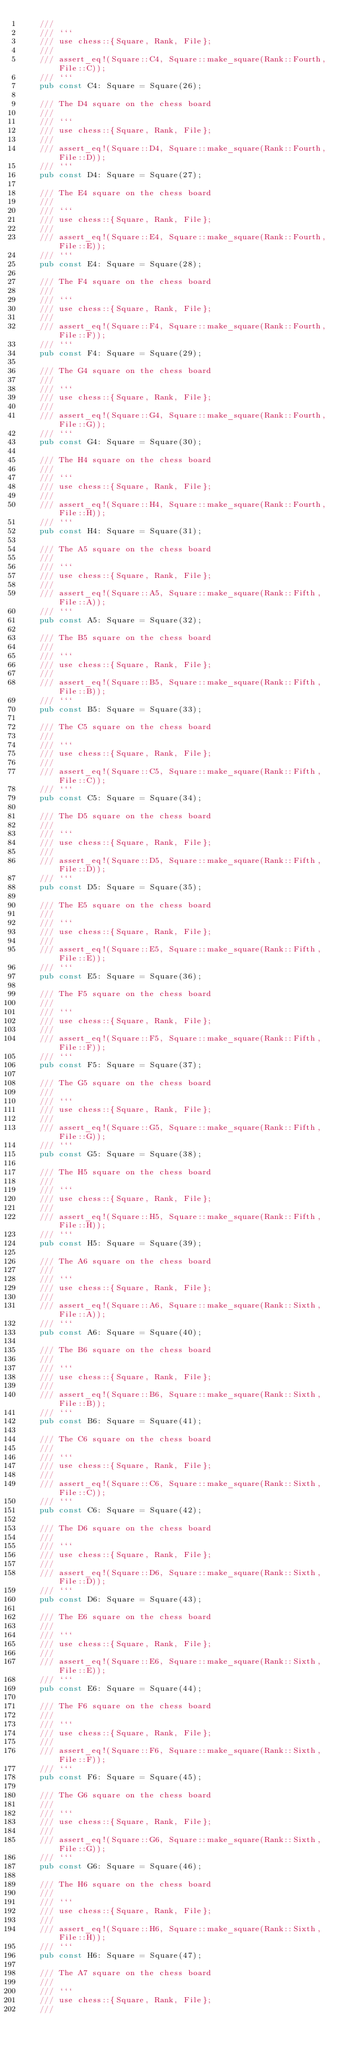<code> <loc_0><loc_0><loc_500><loc_500><_Rust_>    ///
    /// ```
    /// use chess::{Square, Rank, File};
    ///
    /// assert_eq!(Square::C4, Square::make_square(Rank::Fourth, File::C));
    /// ```
    pub const C4: Square = Square(26);

    /// The D4 square on the chess board
    ///
    /// ```
    /// use chess::{Square, Rank, File};
    ///
    /// assert_eq!(Square::D4, Square::make_square(Rank::Fourth, File::D));
    /// ```
    pub const D4: Square = Square(27);

    /// The E4 square on the chess board
    ///
    /// ```
    /// use chess::{Square, Rank, File};
    ///
    /// assert_eq!(Square::E4, Square::make_square(Rank::Fourth, File::E));
    /// ```
    pub const E4: Square = Square(28);

    /// The F4 square on the chess board
    ///
    /// ```
    /// use chess::{Square, Rank, File};
    ///
    /// assert_eq!(Square::F4, Square::make_square(Rank::Fourth, File::F));
    /// ```
    pub const F4: Square = Square(29);

    /// The G4 square on the chess board
    ///
    /// ```
    /// use chess::{Square, Rank, File};
    ///
    /// assert_eq!(Square::G4, Square::make_square(Rank::Fourth, File::G));
    /// ```
    pub const G4: Square = Square(30);

    /// The H4 square on the chess board
    ///
    /// ```
    /// use chess::{Square, Rank, File};
    ///
    /// assert_eq!(Square::H4, Square::make_square(Rank::Fourth, File::H));
    /// ```
    pub const H4: Square = Square(31);

    /// The A5 square on the chess board
    ///
    /// ```
    /// use chess::{Square, Rank, File};
    ///
    /// assert_eq!(Square::A5, Square::make_square(Rank::Fifth, File::A));
    /// ```
    pub const A5: Square = Square(32);

    /// The B5 square on the chess board
    ///
    /// ```
    /// use chess::{Square, Rank, File};
    ///
    /// assert_eq!(Square::B5, Square::make_square(Rank::Fifth, File::B));
    /// ```
    pub const B5: Square = Square(33);

    /// The C5 square on the chess board
    ///
    /// ```
    /// use chess::{Square, Rank, File};
    ///
    /// assert_eq!(Square::C5, Square::make_square(Rank::Fifth, File::C));
    /// ```
    pub const C5: Square = Square(34);

    /// The D5 square on the chess board
    ///
    /// ```
    /// use chess::{Square, Rank, File};
    ///
    /// assert_eq!(Square::D5, Square::make_square(Rank::Fifth, File::D));
    /// ```
    pub const D5: Square = Square(35);

    /// The E5 square on the chess board
    ///
    /// ```
    /// use chess::{Square, Rank, File};
    ///
    /// assert_eq!(Square::E5, Square::make_square(Rank::Fifth, File::E));
    /// ```
    pub const E5: Square = Square(36);

    /// The F5 square on the chess board
    ///
    /// ```
    /// use chess::{Square, Rank, File};
    ///
    /// assert_eq!(Square::F5, Square::make_square(Rank::Fifth, File::F));
    /// ```
    pub const F5: Square = Square(37);

    /// The G5 square on the chess board
    ///
    /// ```
    /// use chess::{Square, Rank, File};
    ///
    /// assert_eq!(Square::G5, Square::make_square(Rank::Fifth, File::G));
    /// ```
    pub const G5: Square = Square(38);

    /// The H5 square on the chess board
    ///
    /// ```
    /// use chess::{Square, Rank, File};
    ///
    /// assert_eq!(Square::H5, Square::make_square(Rank::Fifth, File::H));
    /// ```
    pub const H5: Square = Square(39);

    /// The A6 square on the chess board
    ///
    /// ```
    /// use chess::{Square, Rank, File};
    ///
    /// assert_eq!(Square::A6, Square::make_square(Rank::Sixth, File::A));
    /// ```
    pub const A6: Square = Square(40);

    /// The B6 square on the chess board
    ///
    /// ```
    /// use chess::{Square, Rank, File};
    ///
    /// assert_eq!(Square::B6, Square::make_square(Rank::Sixth, File::B));
    /// ```
    pub const B6: Square = Square(41);

    /// The C6 square on the chess board
    ///
    /// ```
    /// use chess::{Square, Rank, File};
    ///
    /// assert_eq!(Square::C6, Square::make_square(Rank::Sixth, File::C));
    /// ```
    pub const C6: Square = Square(42);

    /// The D6 square on the chess board
    ///
    /// ```
    /// use chess::{Square, Rank, File};
    ///
    /// assert_eq!(Square::D6, Square::make_square(Rank::Sixth, File::D));
    /// ```
    pub const D6: Square = Square(43);

    /// The E6 square on the chess board
    ///
    /// ```
    /// use chess::{Square, Rank, File};
    ///
    /// assert_eq!(Square::E6, Square::make_square(Rank::Sixth, File::E));
    /// ```
    pub const E6: Square = Square(44);

    /// The F6 square on the chess board
    ///
    /// ```
    /// use chess::{Square, Rank, File};
    ///
    /// assert_eq!(Square::F6, Square::make_square(Rank::Sixth, File::F));
    /// ```
    pub const F6: Square = Square(45);

    /// The G6 square on the chess board
    ///
    /// ```
    /// use chess::{Square, Rank, File};
    ///
    /// assert_eq!(Square::G6, Square::make_square(Rank::Sixth, File::G));
    /// ```
    pub const G6: Square = Square(46);

    /// The H6 square on the chess board
    ///
    /// ```
    /// use chess::{Square, Rank, File};
    ///
    /// assert_eq!(Square::H6, Square::make_square(Rank::Sixth, File::H));
    /// ```
    pub const H6: Square = Square(47);

    /// The A7 square on the chess board
    ///
    /// ```
    /// use chess::{Square, Rank, File};
    ///</code> 